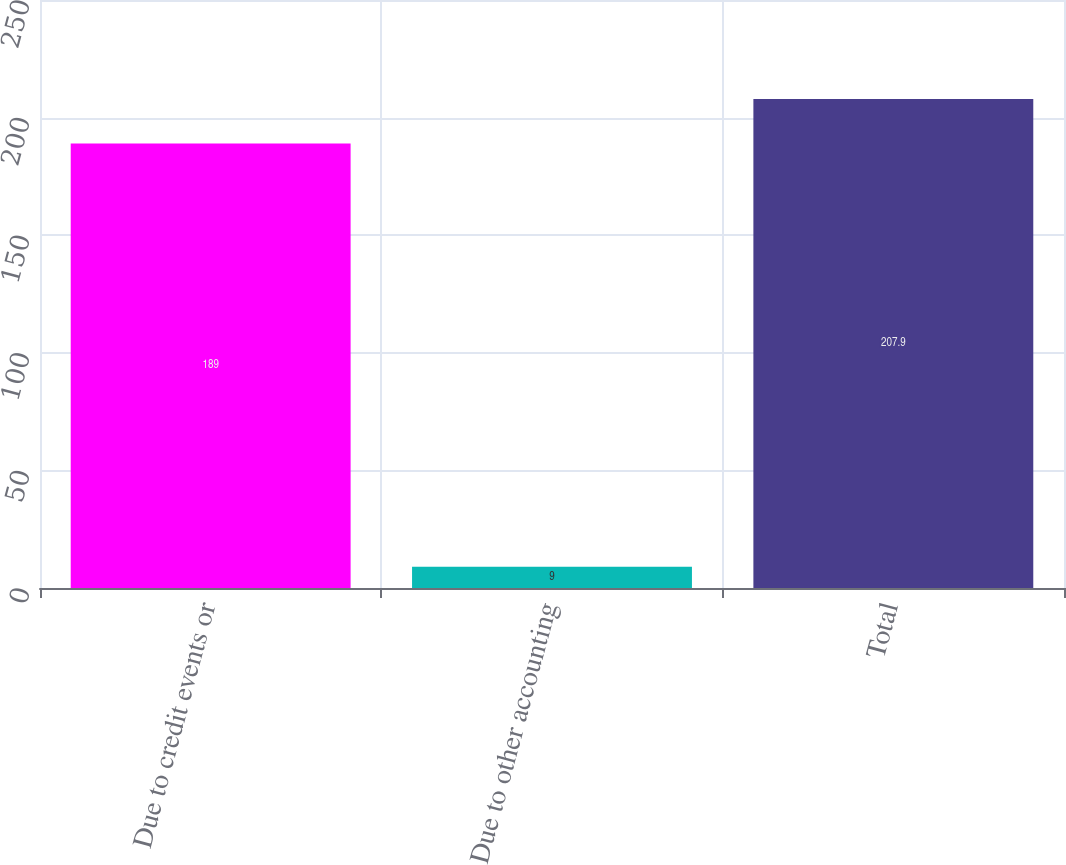Convert chart. <chart><loc_0><loc_0><loc_500><loc_500><bar_chart><fcel>Due to credit events or<fcel>Due to other accounting<fcel>Total<nl><fcel>189<fcel>9<fcel>207.9<nl></chart> 